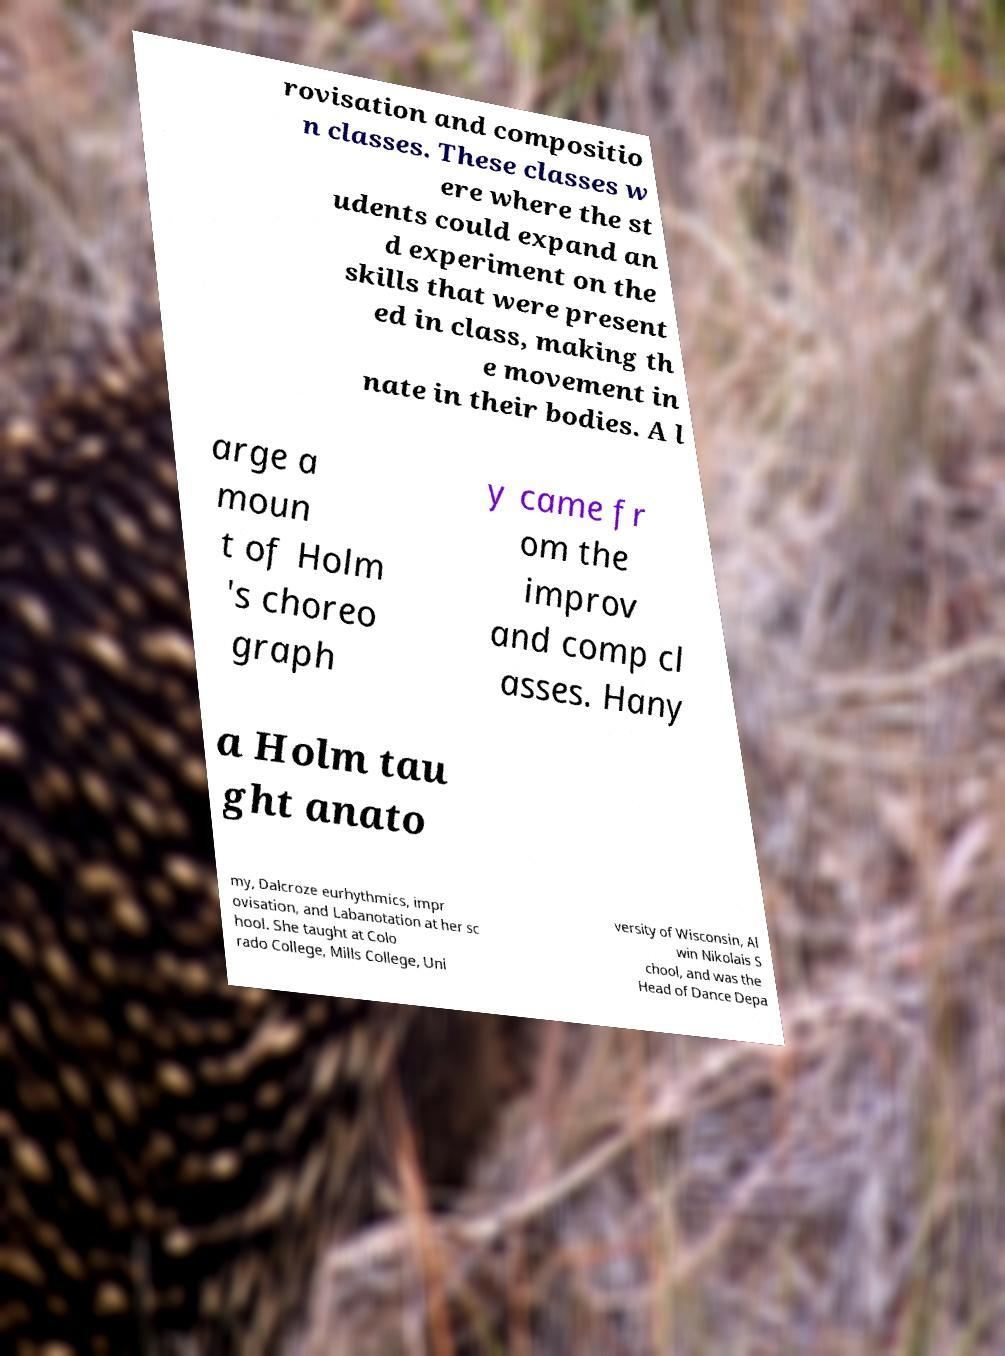Can you read and provide the text displayed in the image?This photo seems to have some interesting text. Can you extract and type it out for me? rovisation and compositio n classes. These classes w ere where the st udents could expand an d experiment on the skills that were present ed in class, making th e movement in nate in their bodies. A l arge a moun t of Holm 's choreo graph y came fr om the improv and comp cl asses. Hany a Holm tau ght anato my, Dalcroze eurhythmics, impr ovisation, and Labanotation at her sc hool. She taught at Colo rado College, Mills College, Uni versity of Wisconsin, Al win Nikolais S chool, and was the Head of Dance Depa 